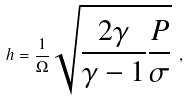<formula> <loc_0><loc_0><loc_500><loc_500>h = \frac { 1 } { \Omega } \sqrt { \frac { 2 \gamma } { \gamma - 1 } \frac { P } { \sigma } } \ ,</formula> 